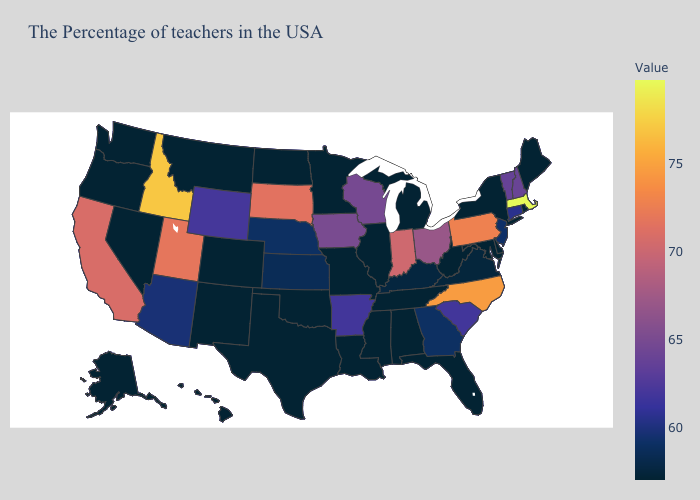Does Utah have the highest value in the USA?
Give a very brief answer. No. Is the legend a continuous bar?
Short answer required. Yes. Which states have the lowest value in the USA?
Give a very brief answer. Maine, New York, Delaware, Maryland, West Virginia, Florida, Michigan, Alabama, Tennessee, Illinois, Mississippi, Louisiana, Missouri, Minnesota, Oklahoma, Texas, North Dakota, Colorado, New Mexico, Montana, Nevada, Washington, Oregon, Alaska, Hawaii. Among the states that border Washington , which have the highest value?
Answer briefly. Idaho. 